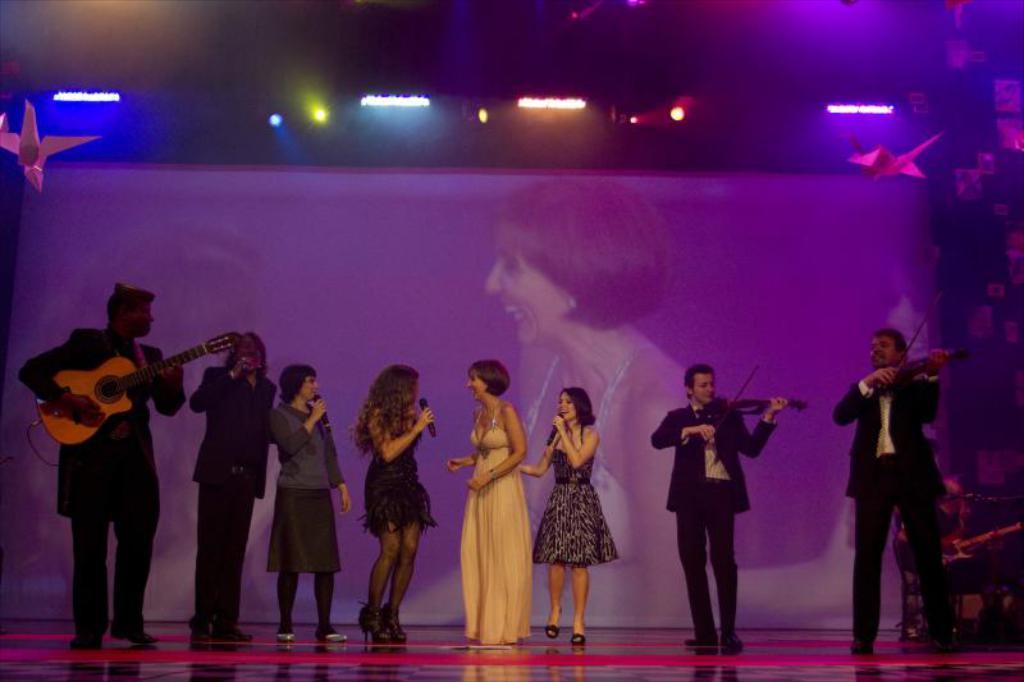What is happening in the image? There is a group of people standing on a stage. What are some of the people in the group doing? Some people in the group are playing musical instruments. What type of flesh can be seen on the stage in the image? There is no flesh visible in the image; it features a group of people standing on a stage, some of whom are playing musical instruments. 